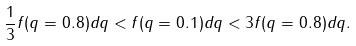<formula> <loc_0><loc_0><loc_500><loc_500>\frac { 1 } { 3 } f ( q = 0 . 8 ) d q < f ( q = 0 . 1 ) d q < 3 f ( q = 0 . 8 ) d q .</formula> 